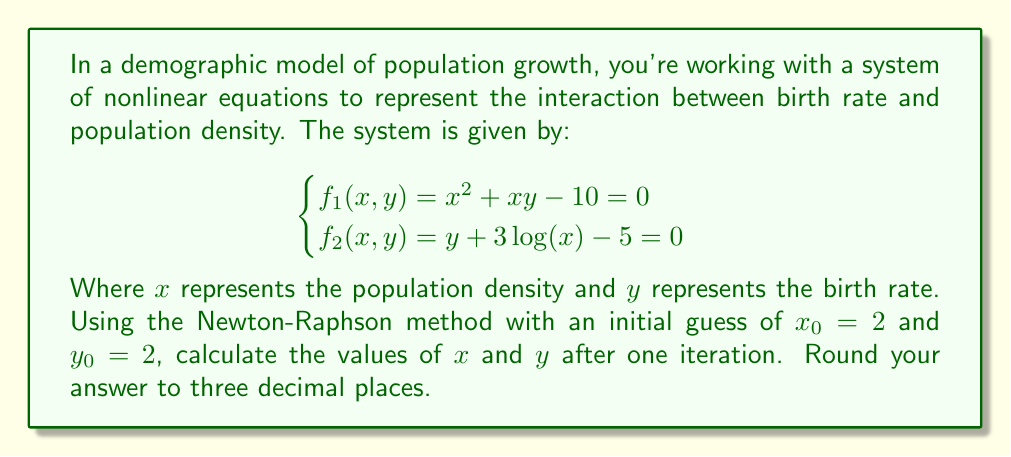Teach me how to tackle this problem. To solve this system using the Newton-Raphson method, we follow these steps:

1) First, we need to calculate the Jacobian matrix:

   $$J = \begin{bmatrix}
   \frac{\partial f_1}{\partial x} & \frac{\partial f_1}{\partial y} \\
   \frac{\partial f_2}{\partial x} & \frac{\partial f_2}{\partial y}
   \end{bmatrix} = \begin{bmatrix}
   2x + y & x \\
   \frac{3}{x} & 1
   \end{bmatrix}$$

2) Next, we evaluate the functions and the Jacobian at the initial point $(x_0, y_0) = (2, 2)$:

   $$f_1(2,2) = 2^2 + 2(2) - 10 = -2$$
   $$f_2(2,2) = 2 + 3\log(2) - 5 \approx -0.9205$$

   $$J(2,2) = \begin{bmatrix}
   2(2) + 2 & 2 \\
   \frac{3}{2} & 1
   \end{bmatrix} = \begin{bmatrix}
   6 & 2 \\
   1.5 & 1
   \end{bmatrix}$$

3) The Newton-Raphson iteration is given by:

   $$\begin{bmatrix} x_{1} \\ y_{1} \end{bmatrix} = \begin{bmatrix} x_{0} \\ y_{0} \end{bmatrix} - J^{-1}(x_0, y_0) \begin{bmatrix} f_1(x_0, y_0) \\ f_2(x_0, y_0) \end{bmatrix}$$

4) We need to calculate $J^{-1}$:

   $$J^{-1} = \frac{1}{6-3} \begin{bmatrix}
   1 & -2 \\
   -1.5 & 6
   \end{bmatrix} = \begin{bmatrix}
   0.3333 & -0.6667 \\
   -0.5 & 2
   \end{bmatrix}$$

5) Now we can perform the iteration:

   $$\begin{bmatrix} x_{1} \\ y_{1} \end{bmatrix} = \begin{bmatrix} 2 \\ 2 \end{bmatrix} - \begin{bmatrix}
   0.3333 & -0.6667 \\
   -0.5 & 2
   \end{bmatrix} \begin{bmatrix} -2 \\ -0.9205 \end{bmatrix}$$

6) Calculating this:

   $$\begin{bmatrix} x_{1} \\ y_{1} \end{bmatrix} = \begin{bmatrix} 2 \\ 2 \end{bmatrix} + \begin{bmatrix}
   0.0564 \\
   0.8410
   \end{bmatrix} = \begin{bmatrix}
   2.0564 \\
   2.8410
   \end{bmatrix}$$

7) Rounding to three decimal places:

   $$x_1 \approx 2.056$$
   $$y_1 \approx 2.841$$
Answer: $x \approx 2.056$, $y \approx 2.841$ 